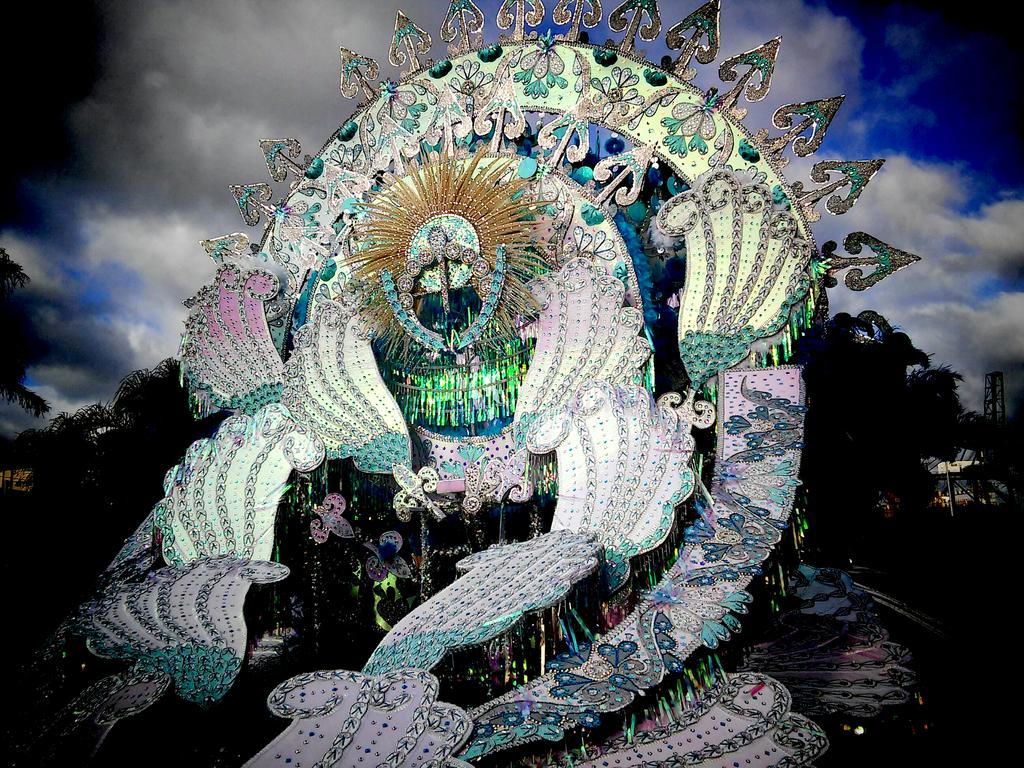What is the main subject of the image? There is an art piece in the center of the image. What else can be seen in the image besides the art piece? There are decor items in the image. What is visible in the background of the image? There are trees and poles in the background of the image. What is visible in the sky at the top of the image? There are clouds visible in the sky at the top of the image. What is the name of the son who is sneezing in the image? There is no person, let alone a son, present in the image. The image features an art piece, decor items, trees, poles, and clouds. 